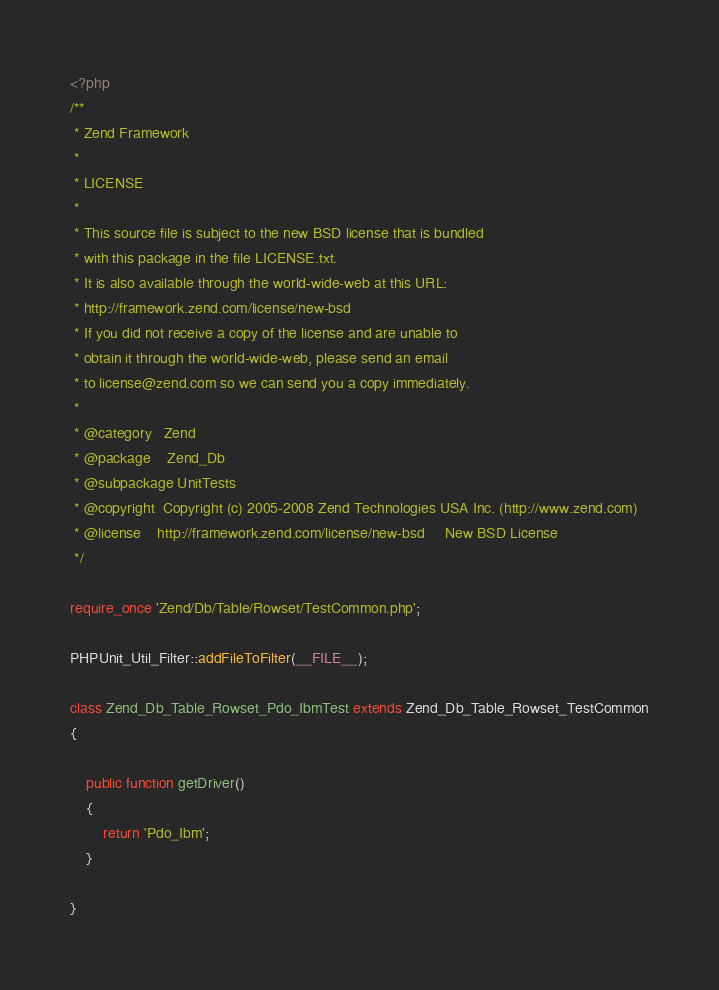Convert code to text. <code><loc_0><loc_0><loc_500><loc_500><_PHP_><?php
/**
 * Zend Framework
 *
 * LICENSE
 *
 * This source file is subject to the new BSD license that is bundled
 * with this package in the file LICENSE.txt.
 * It is also available through the world-wide-web at this URL:
 * http://framework.zend.com/license/new-bsd
 * If you did not receive a copy of the license and are unable to
 * obtain it through the world-wide-web, please send an email
 * to license@zend.com so we can send you a copy immediately.
 *
 * @category   Zend
 * @package    Zend_Db
 * @subpackage UnitTests
 * @copyright  Copyright (c) 2005-2008 Zend Technologies USA Inc. (http://www.zend.com)
 * @license    http://framework.zend.com/license/new-bsd     New BSD License
 */

require_once 'Zend/Db/Table/Rowset/TestCommon.php';

PHPUnit_Util_Filter::addFileToFilter(__FILE__);

class Zend_Db_Table_Rowset_Pdo_IbmTest extends Zend_Db_Table_Rowset_TestCommon
{

    public function getDriver()
    {
        return 'Pdo_Ibm';
    }

}</code> 